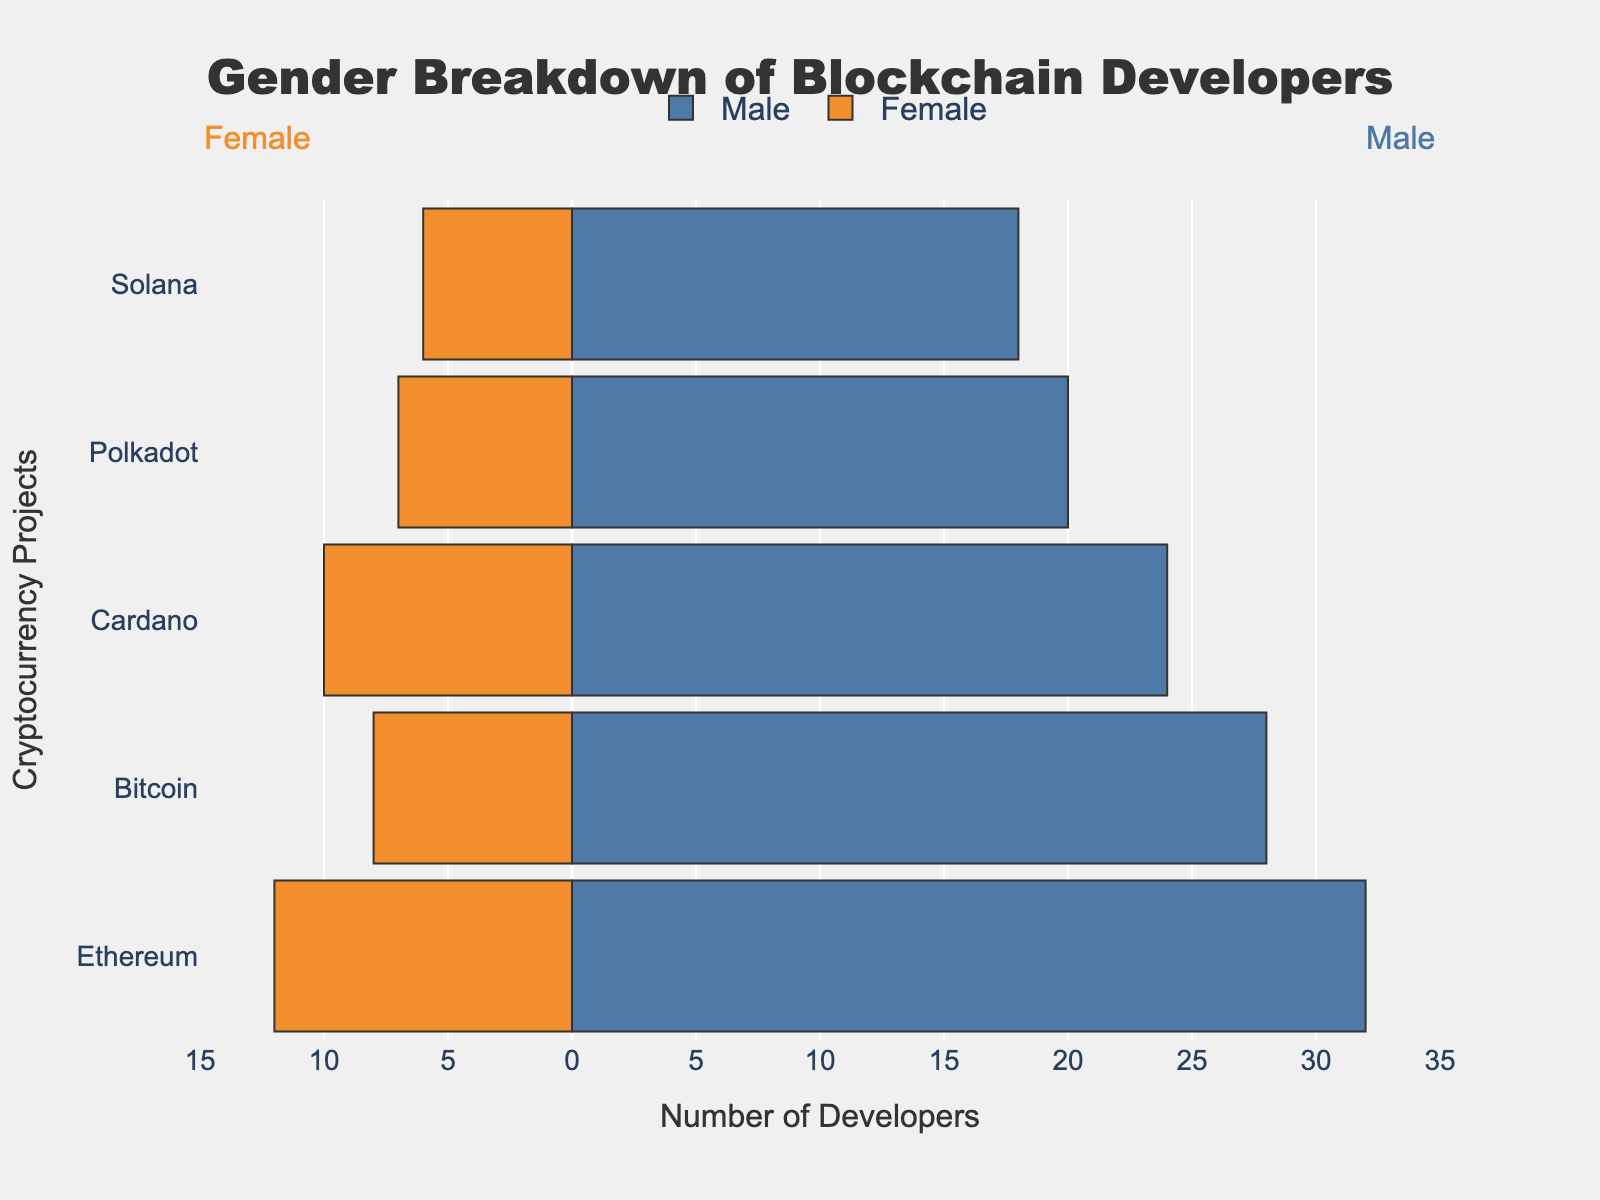Which cryptocurrency project has the highest number of male developers? To find the highest number of male developers, look at the blue bars representing male developers for each cryptocurrency. Ethereum has the longest blue bar, indicating the highest number at 32 males.
Answer: Ethereum How many female developers are there in the Solana project? The female developers for each project are represented by the orange bars with negative values. For Solana, the length of the orange bar corresponds to -6, indicating 6 female developers.
Answer: 6 What is the total number of developers (male and female) for Cardano? Summing the number of male and female developers for Cardano: 24 (male) + 10 (female) = 34.
Answer: 34 Which cryptocurrency project has the smallest gender gap in the number of developers? The gender gap is the difference between the number of male and female developers. Calculate the gap for each project: Ethereum (32-12=20), Bitcoin (28-8=20), Cardano (24-10=14), Polkadot (20-7=13), Solana (18-6=12). Solana has the smallest gap.
Answer: Solana In which project are female developers closest in number to male developers? To determine this, find the project with the smallest difference between male and female developers. Calculated previously, Solana (gap of 12) is the closest.
Answer: Solana What is the average number of male developers across all projects? Add the number of male developers and divide by the number of projects: (32 + 28 + 24 + 20 + 18) / 5 = 24.4.
Answer: 24.4 Compare the number of female developers in Ethereum and Bitcoin. Which has more? By comparing the orange bars of Ethereum and Bitcoin, Ethereum has 12 female developers and Bitcoin has 8. Hence, Ethereum has more female developers.
Answer: Ethereum Which project has the most balanced representation of male and female developers? The most balanced representation of male and female developers will have the smallest difference between their numbers. Solana (18 males, 6 females) with a difference of 12 is this project.
Answer: Solana How many more male developers are there in Bitcoin compared to Polkadot? Subtract the number of male developers in Polkadot from Bitcoin: 28 - 20 = 8.
Answer: 8 Is there any project where male developers are more than three times the number of female developers? Check each project to see if the number of male developers is more than three times the number of female developers: Ethereum (32 > 3*12 => 32 > 36, No), Bitcoin (28 > 3*8 => 28 > 24, Yes), Cardano (24 > 3*10 => 24 > 30, No), Polkadot (20 > 3*7 => 20 > 21, No), Solana (18 > 3*6 => 18 > 18, No). Only Bitcoin satisfies this condition.
Answer: Bitcoin 